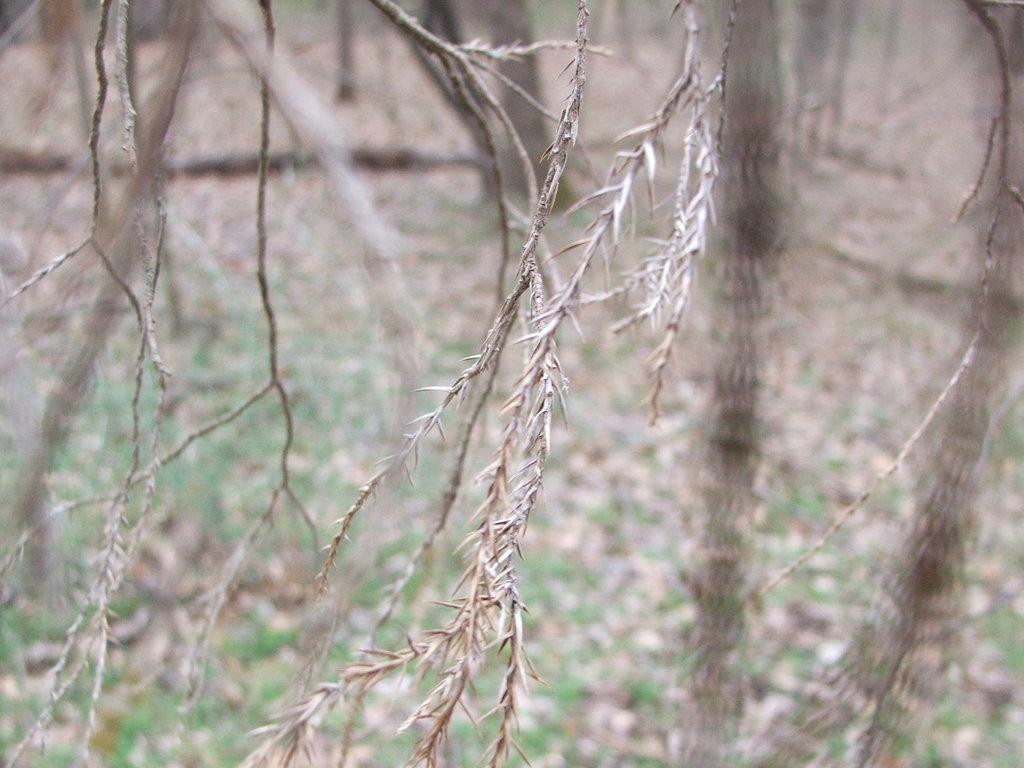What type of vegetation can be seen in the image? There are branches visible in the image. What is visible in the background of the image? There are trees, grass, and dry leaves in the background of the image. What type of iron is visible in the image? There is no iron present in the image; it features branches, trees, grass, and dry leaves. 